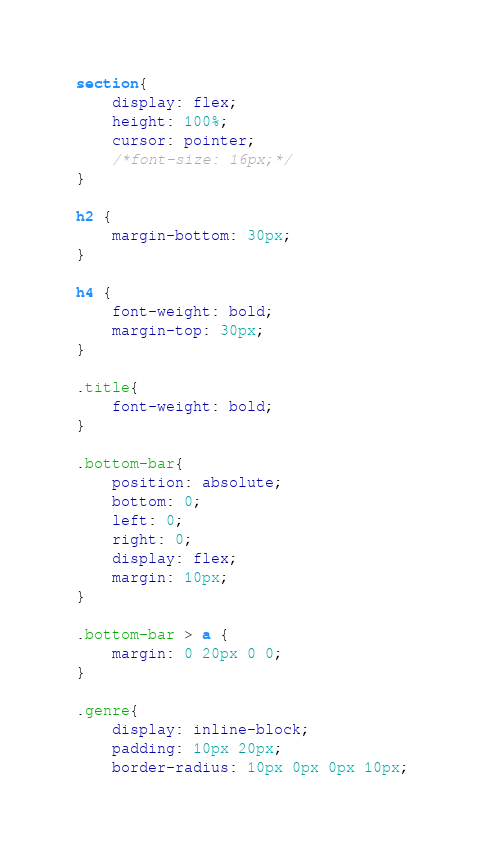Convert code to text. <code><loc_0><loc_0><loc_500><loc_500><_CSS_>section{
    display: flex;
    height: 100%;
    cursor: pointer;
    /*font-size: 16px;*/
}

h2 {
    margin-bottom: 30px;
}

h4 {
    font-weight: bold;
    margin-top: 30px;
}

.title{
    font-weight: bold;
}

.bottom-bar{
    position: absolute;
    bottom: 0;
    left: 0;
    right: 0;
    display: flex;
    margin: 10px;
}

.bottom-bar > a {
    margin: 0 20px 0 0;
}

.genre{
    display: inline-block;
    padding: 10px 20px;
    border-radius: 10px 0px 0px 10px;</code> 